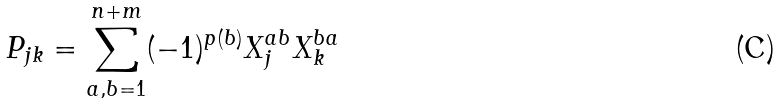<formula> <loc_0><loc_0><loc_500><loc_500>P _ { j k } = \sum _ { a , b = 1 } ^ { n + m } ( - 1 ) ^ { p ( b ) } X _ { j } ^ { a b } X _ { k } ^ { b a }</formula> 